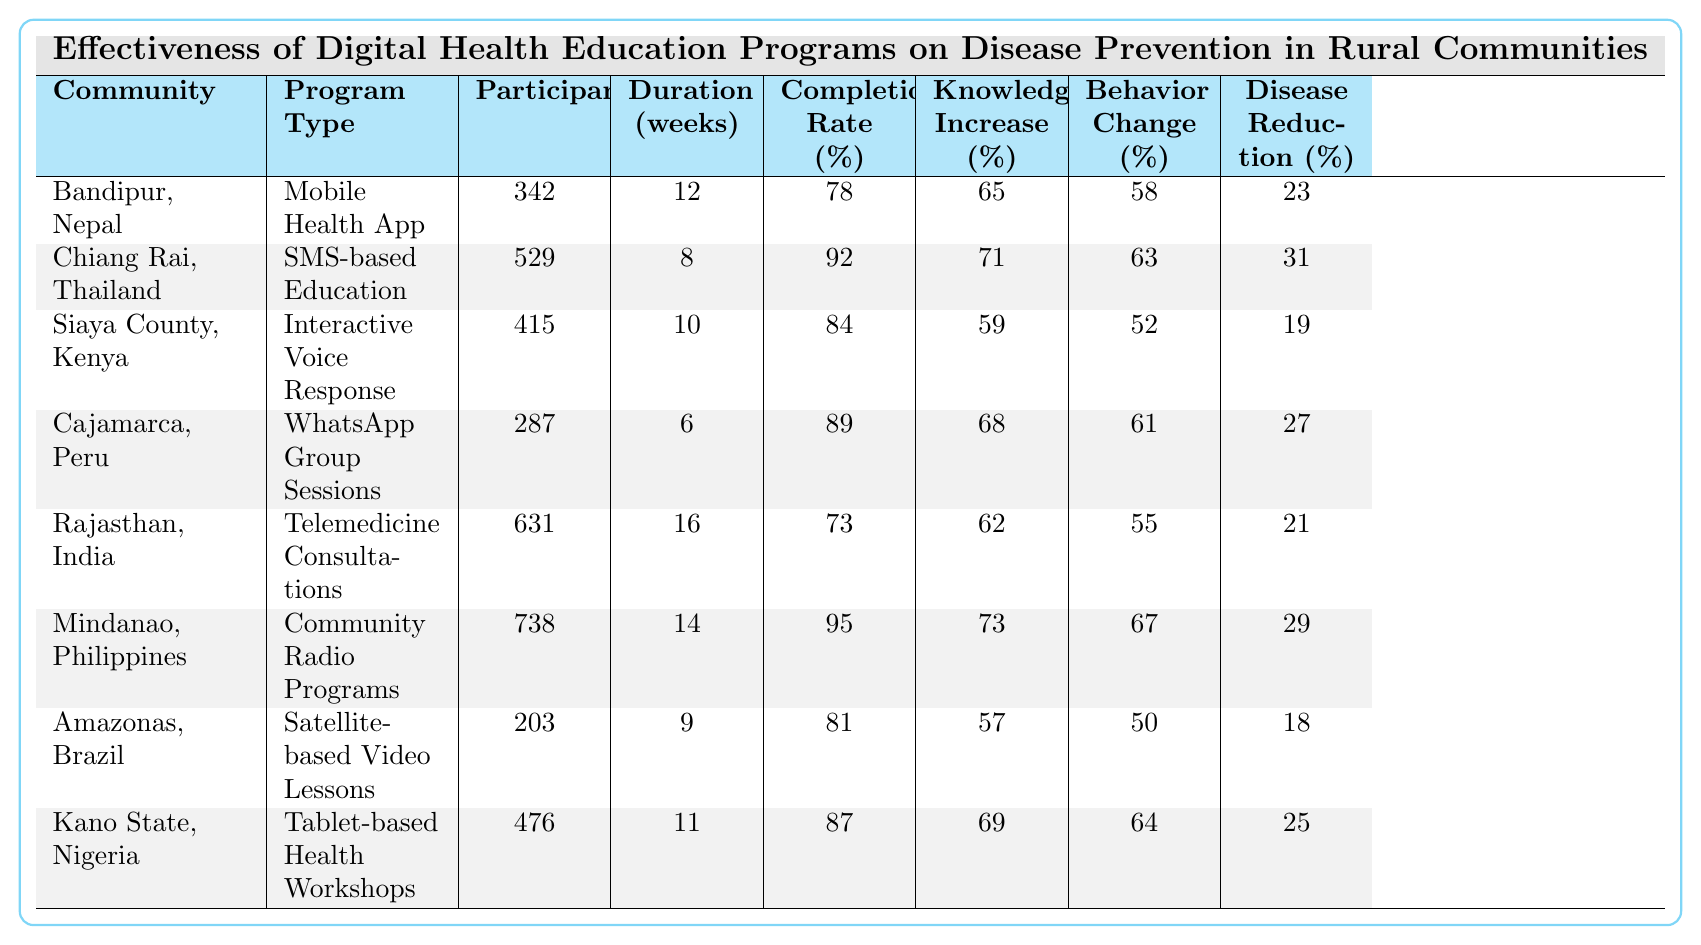What is the highest completion rate among the digital health education programs? Looking at the "Completion Rate (%)" column, the highest value is 95% for the Mindanao, Philippines program.
Answer: 95% Which community had the lowest increase in disease prevention knowledge? By examining the "Disease Prevention Knowledge Increase (%)" column, the lowest increase is 57% in Amazonas, Brazil.
Answer: 57% What is the total number of participants across all eight programs? Adding all the participants from the "Participants" column: (342 + 529 + 415 + 287 + 631 + 738 + 203 + 476) = 3121.
Answer: 3121 Which community reported the greatest behavior change percentage, and what was that percentage? The highest "Reported Behavior Change (%)" is 67% for the Mindanao, Philippines program.
Answer: 67% Is there a community with a reduction in disease incidence higher than 30%? By checking the "Reduction in Disease Incidence (%)" column, Chiang Rai, Thailand has a 31% reduction, which is higher than 30%.
Answer: Yes Calculate the average duration of the programs in weeks. To find the average, sum the durations: (12 + 8 + 10 + 6 + 16 + 14 + 9 + 11) = 96 weeks. Then divide by the number of programs (8). 96/8 = 12 weeks.
Answer: 12 weeks Which program type had the highest number of participants? Looking at the "Participants" column, the program with the most participants is "Community Radio Programs" in Mindanao, Philippines with 738 participants.
Answer: Community Radio Programs Compare the completion rates of the mobile health app and tablet-based health workshops. Which has a higher rate? The "Completion Rate (%)" for the Mobile Health App is 78%, while the Tablet-based Health Workshops have a completion rate of 87%. 87% is greater than 78%.
Answer: Tablet-based health workshops Which community experienced the least reduction in disease incidence, and what was the percentage? The "Reduction in Disease Incidence (%)" column shows Amazonas, Brazil with the lowest at 18%.
Answer: 18% What is the total percentage increase in disease prevention knowledge for the programs with a duration of more than 10 weeks? The programs with duration more than 10 weeks are Bandipur (65%), Siaya County (59%), Mindanao (73%), and Kano State (69%). Total = (65 + 59 + 73 + 69) = 266%. The average of these is 266/4 = 66.5%.
Answer: 66.5% 